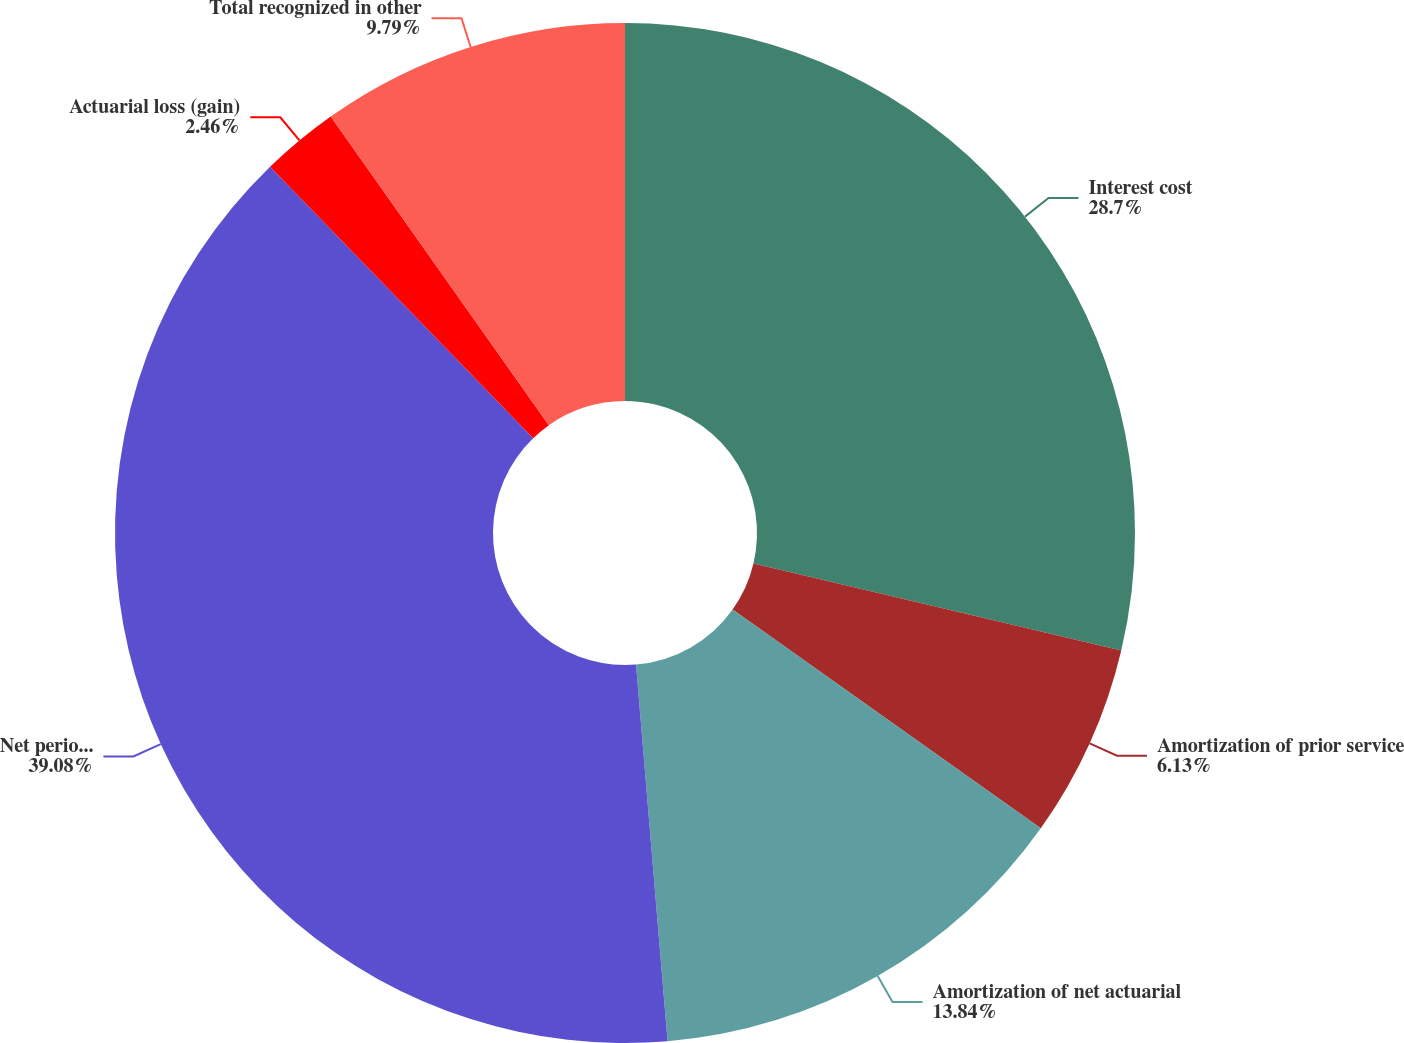<chart> <loc_0><loc_0><loc_500><loc_500><pie_chart><fcel>Interest cost<fcel>Amortization of prior service<fcel>Amortization of net actuarial<fcel>Net periodic benefit (credit)<fcel>Actuarial loss (gain)<fcel>Total recognized in other<nl><fcel>28.7%<fcel>6.13%<fcel>13.84%<fcel>39.08%<fcel>2.46%<fcel>9.79%<nl></chart> 